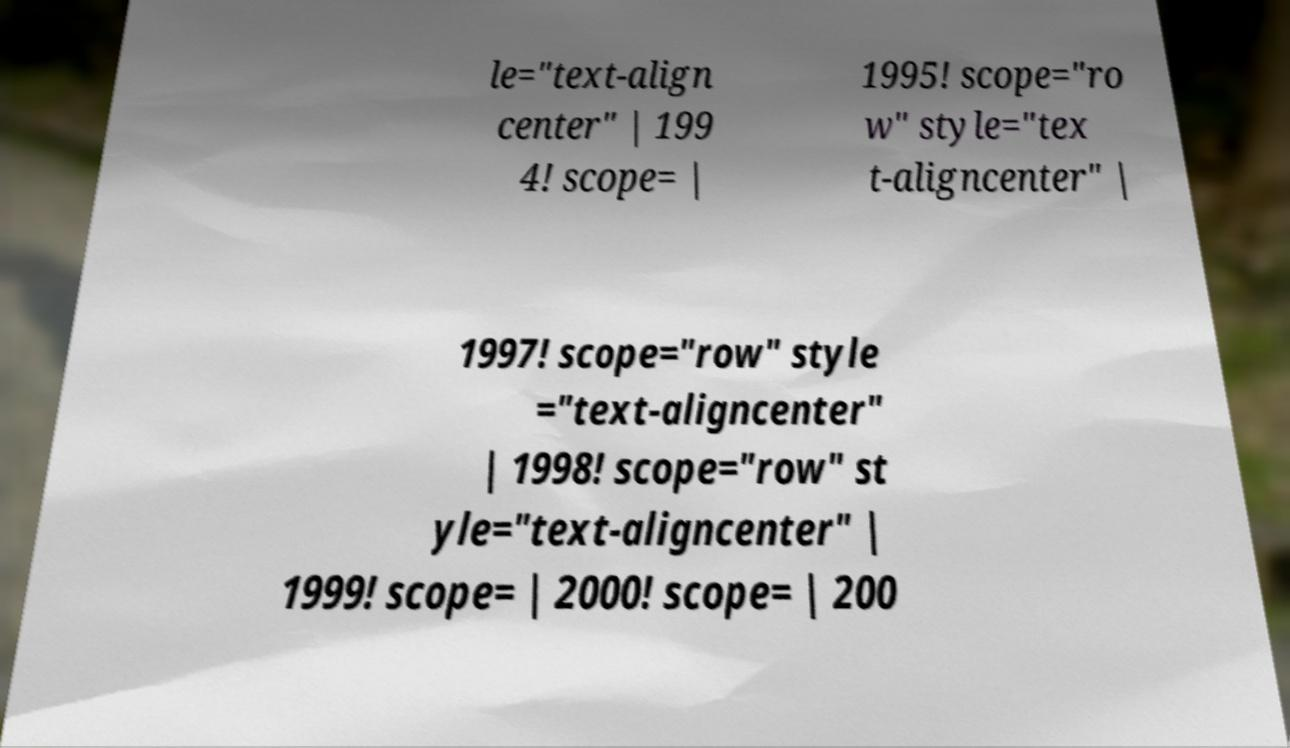Could you extract and type out the text from this image? le="text-align center" | 199 4! scope= | 1995! scope="ro w" style="tex t-aligncenter" | 1997! scope="row" style ="text-aligncenter" | 1998! scope="row" st yle="text-aligncenter" | 1999! scope= | 2000! scope= | 200 